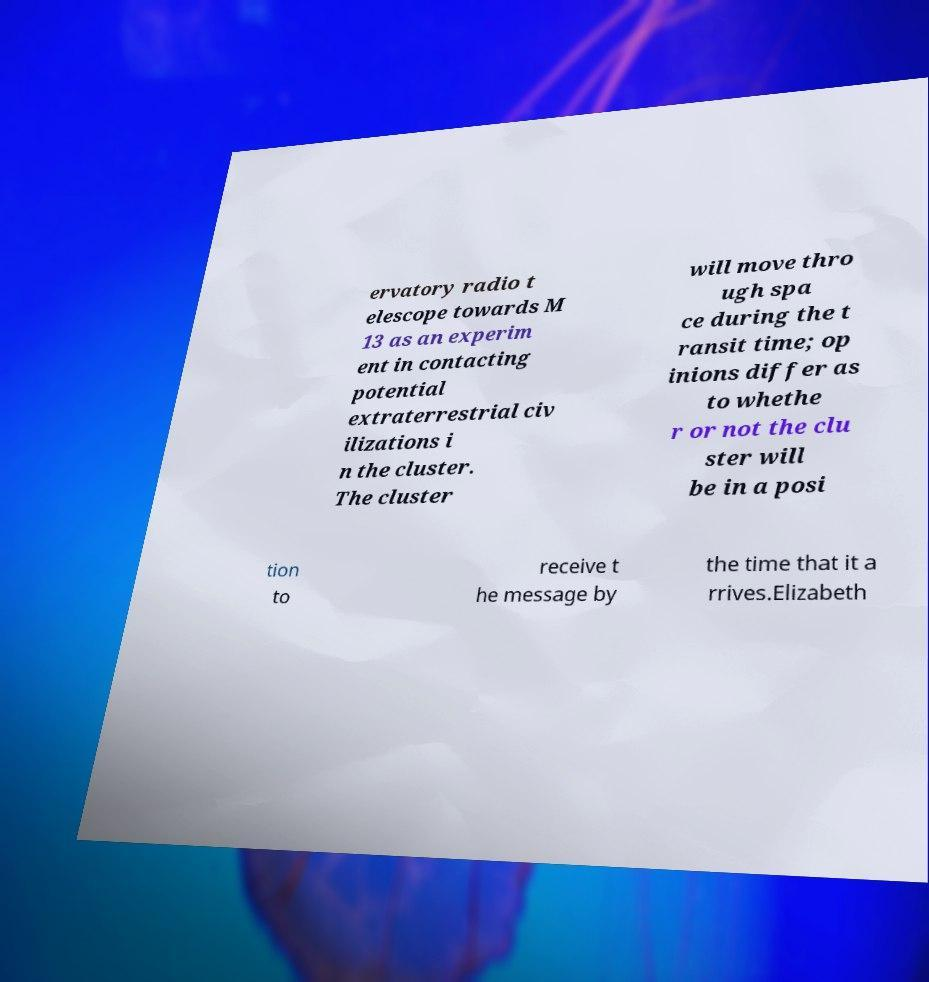For documentation purposes, I need the text within this image transcribed. Could you provide that? ervatory radio t elescope towards M 13 as an experim ent in contacting potential extraterrestrial civ ilizations i n the cluster. The cluster will move thro ugh spa ce during the t ransit time; op inions differ as to whethe r or not the clu ster will be in a posi tion to receive t he message by the time that it a rrives.Elizabeth 